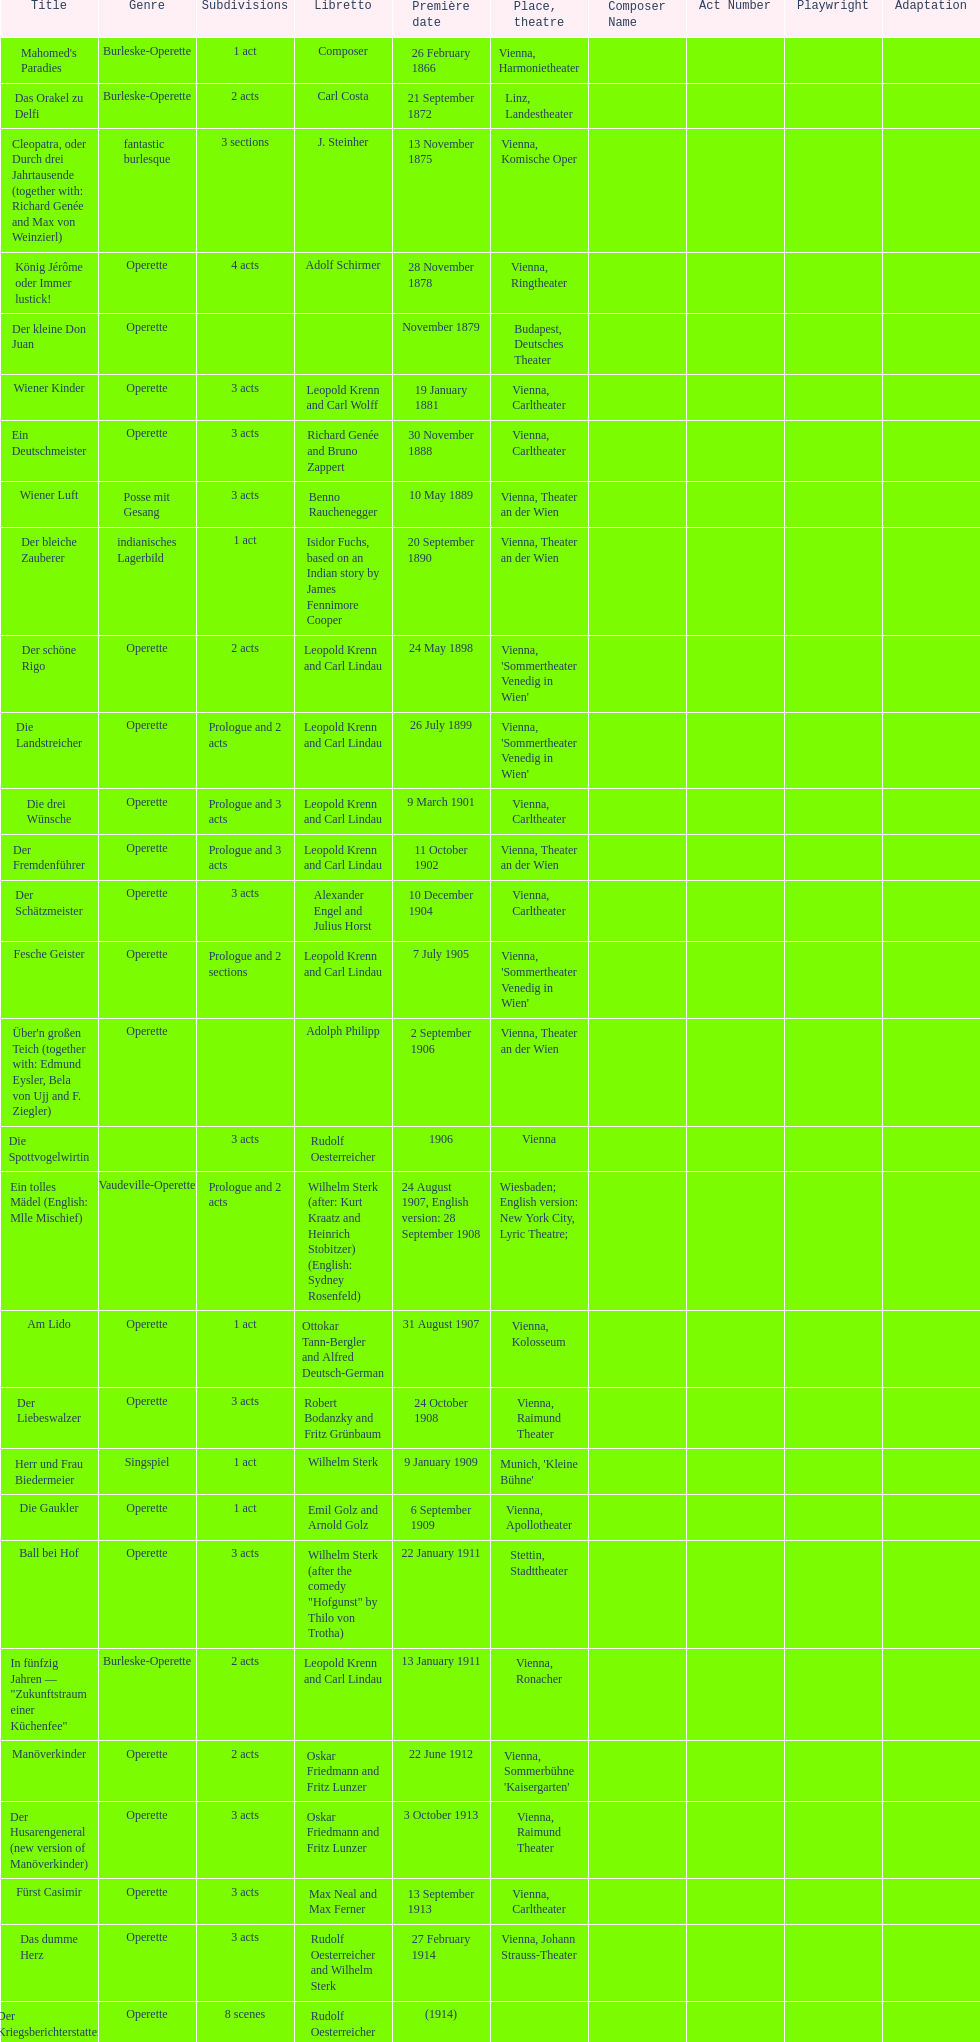What is the latest year for all the dates? 1958. 